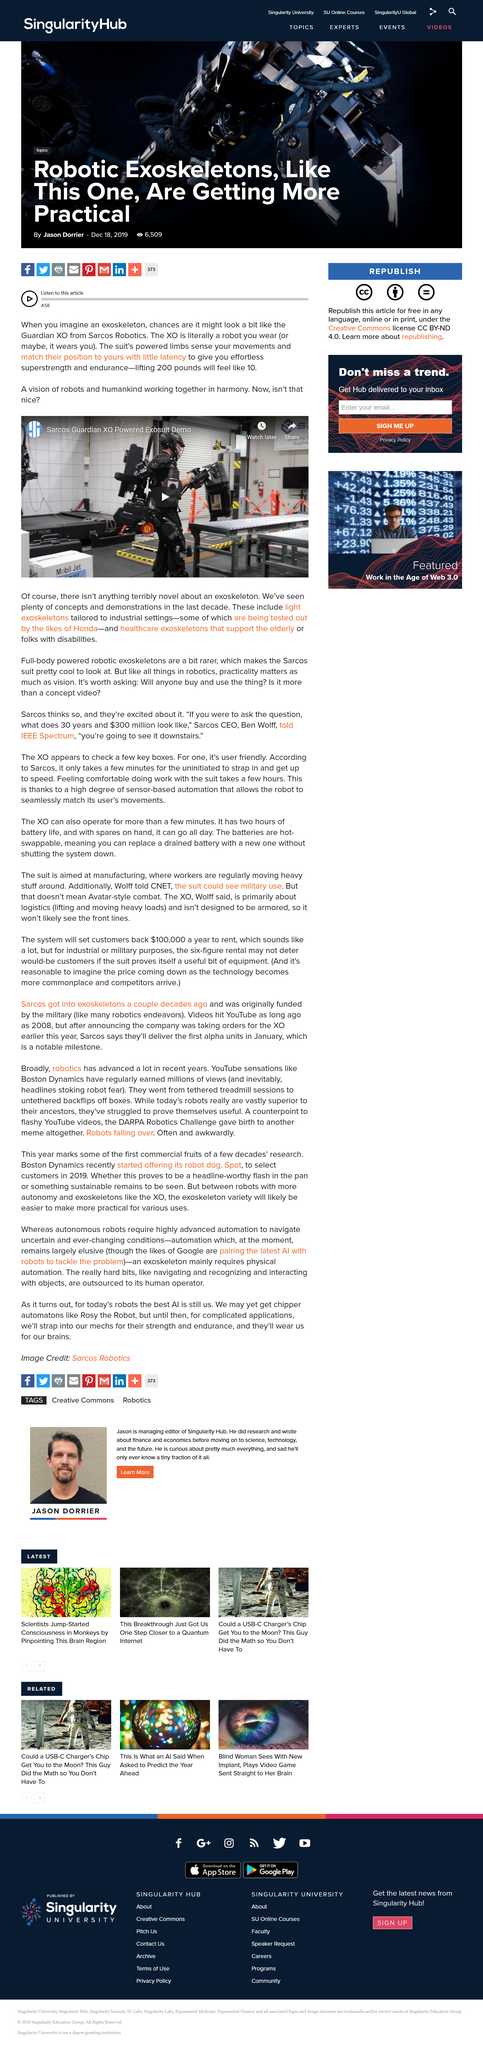Outline some significant characteristics in this image. Exoskeletons, which allow humans and robots to work together in harmony, offer a promising solution to the challenges posed by the increasing demand for automation in the workplace. When wearing the Guardian XO, 200 pounds feels like approximately 10 pounds. The Guardian XO was created by Sarcos Robotics, a company known for its cutting-edge technology and innovative designs. 